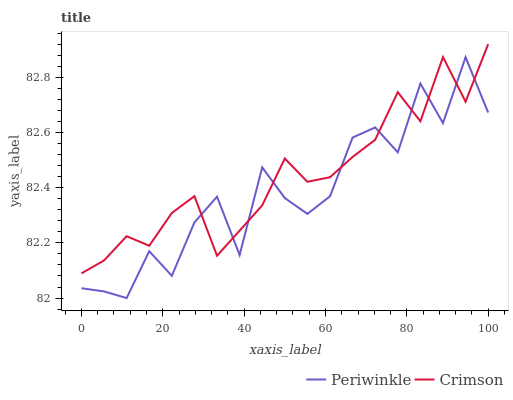Does Periwinkle have the maximum area under the curve?
Answer yes or no. No. Is Periwinkle the smoothest?
Answer yes or no. No. Does Periwinkle have the highest value?
Answer yes or no. No. 